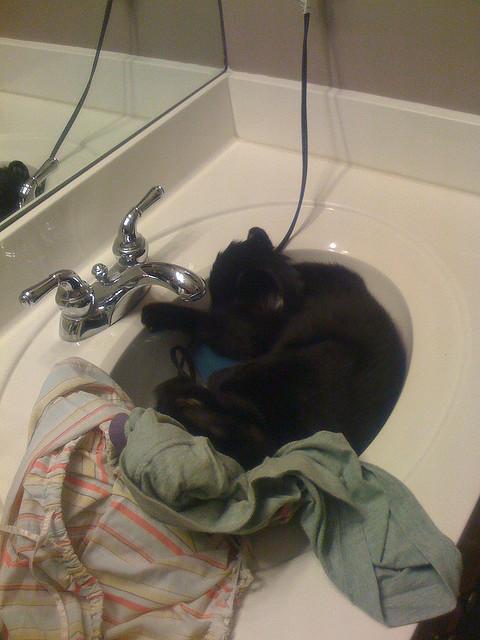Where is the cat?
Keep it brief. Sink. What is the cat doing?
Write a very short answer. Sleeping. What is the cat holding?
Keep it brief. Cord. Is the cat sleeping?
Keep it brief. Yes. 